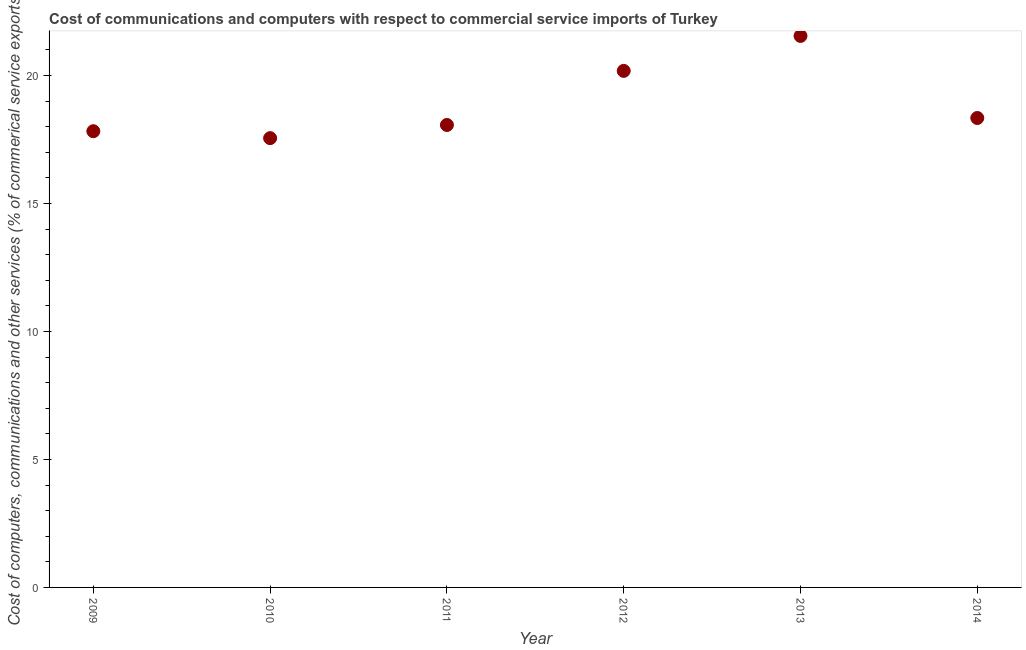What is the  computer and other services in 2011?
Provide a short and direct response. 18.07. Across all years, what is the maximum cost of communications?
Ensure brevity in your answer.  21.55. Across all years, what is the minimum  computer and other services?
Offer a very short reply. 17.56. In which year was the  computer and other services minimum?
Provide a short and direct response. 2010. What is the sum of the cost of communications?
Make the answer very short. 113.53. What is the difference between the  computer and other services in 2010 and 2013?
Provide a succinct answer. -3.99. What is the average  computer and other services per year?
Your answer should be compact. 18.92. What is the median  computer and other services?
Your answer should be very brief. 18.21. Do a majority of the years between 2014 and 2013 (inclusive) have  computer and other services greater than 10 %?
Provide a short and direct response. No. What is the ratio of the cost of communications in 2010 to that in 2013?
Keep it short and to the point. 0.81. Is the cost of communications in 2009 less than that in 2011?
Your answer should be very brief. Yes. Is the difference between the  computer and other services in 2012 and 2013 greater than the difference between any two years?
Offer a very short reply. No. What is the difference between the highest and the second highest cost of communications?
Provide a short and direct response. 1.37. Is the sum of the  computer and other services in 2011 and 2014 greater than the maximum  computer and other services across all years?
Ensure brevity in your answer.  Yes. What is the difference between the highest and the lowest cost of communications?
Keep it short and to the point. 3.99. How many dotlines are there?
Offer a very short reply. 1. What is the difference between two consecutive major ticks on the Y-axis?
Give a very brief answer. 5. Does the graph contain any zero values?
Make the answer very short. No. Does the graph contain grids?
Your response must be concise. No. What is the title of the graph?
Keep it short and to the point. Cost of communications and computers with respect to commercial service imports of Turkey. What is the label or title of the Y-axis?
Your answer should be very brief. Cost of computers, communications and other services (% of commerical service exports). What is the Cost of computers, communications and other services (% of commerical service exports) in 2009?
Ensure brevity in your answer.  17.83. What is the Cost of computers, communications and other services (% of commerical service exports) in 2010?
Provide a succinct answer. 17.56. What is the Cost of computers, communications and other services (% of commerical service exports) in 2011?
Your answer should be very brief. 18.07. What is the Cost of computers, communications and other services (% of commerical service exports) in 2012?
Give a very brief answer. 20.18. What is the Cost of computers, communications and other services (% of commerical service exports) in 2013?
Offer a terse response. 21.55. What is the Cost of computers, communications and other services (% of commerical service exports) in 2014?
Provide a short and direct response. 18.34. What is the difference between the Cost of computers, communications and other services (% of commerical service exports) in 2009 and 2010?
Give a very brief answer. 0.27. What is the difference between the Cost of computers, communications and other services (% of commerical service exports) in 2009 and 2011?
Your answer should be compact. -0.24. What is the difference between the Cost of computers, communications and other services (% of commerical service exports) in 2009 and 2012?
Make the answer very short. -2.36. What is the difference between the Cost of computers, communications and other services (% of commerical service exports) in 2009 and 2013?
Make the answer very short. -3.72. What is the difference between the Cost of computers, communications and other services (% of commerical service exports) in 2009 and 2014?
Your answer should be compact. -0.52. What is the difference between the Cost of computers, communications and other services (% of commerical service exports) in 2010 and 2011?
Ensure brevity in your answer.  -0.51. What is the difference between the Cost of computers, communications and other services (% of commerical service exports) in 2010 and 2012?
Ensure brevity in your answer.  -2.63. What is the difference between the Cost of computers, communications and other services (% of commerical service exports) in 2010 and 2013?
Offer a terse response. -3.99. What is the difference between the Cost of computers, communications and other services (% of commerical service exports) in 2010 and 2014?
Provide a short and direct response. -0.79. What is the difference between the Cost of computers, communications and other services (% of commerical service exports) in 2011 and 2012?
Make the answer very short. -2.11. What is the difference between the Cost of computers, communications and other services (% of commerical service exports) in 2011 and 2013?
Keep it short and to the point. -3.48. What is the difference between the Cost of computers, communications and other services (% of commerical service exports) in 2011 and 2014?
Provide a short and direct response. -0.27. What is the difference between the Cost of computers, communications and other services (% of commerical service exports) in 2012 and 2013?
Ensure brevity in your answer.  -1.37. What is the difference between the Cost of computers, communications and other services (% of commerical service exports) in 2012 and 2014?
Your answer should be compact. 1.84. What is the difference between the Cost of computers, communications and other services (% of commerical service exports) in 2013 and 2014?
Your answer should be very brief. 3.21. What is the ratio of the Cost of computers, communications and other services (% of commerical service exports) in 2009 to that in 2010?
Make the answer very short. 1.01. What is the ratio of the Cost of computers, communications and other services (% of commerical service exports) in 2009 to that in 2011?
Keep it short and to the point. 0.99. What is the ratio of the Cost of computers, communications and other services (% of commerical service exports) in 2009 to that in 2012?
Offer a terse response. 0.88. What is the ratio of the Cost of computers, communications and other services (% of commerical service exports) in 2009 to that in 2013?
Make the answer very short. 0.83. What is the ratio of the Cost of computers, communications and other services (% of commerical service exports) in 2010 to that in 2012?
Make the answer very short. 0.87. What is the ratio of the Cost of computers, communications and other services (% of commerical service exports) in 2010 to that in 2013?
Your response must be concise. 0.81. What is the ratio of the Cost of computers, communications and other services (% of commerical service exports) in 2010 to that in 2014?
Make the answer very short. 0.96. What is the ratio of the Cost of computers, communications and other services (% of commerical service exports) in 2011 to that in 2012?
Offer a terse response. 0.9. What is the ratio of the Cost of computers, communications and other services (% of commerical service exports) in 2011 to that in 2013?
Your answer should be compact. 0.84. What is the ratio of the Cost of computers, communications and other services (% of commerical service exports) in 2012 to that in 2013?
Make the answer very short. 0.94. What is the ratio of the Cost of computers, communications and other services (% of commerical service exports) in 2012 to that in 2014?
Provide a succinct answer. 1.1. What is the ratio of the Cost of computers, communications and other services (% of commerical service exports) in 2013 to that in 2014?
Provide a succinct answer. 1.18. 